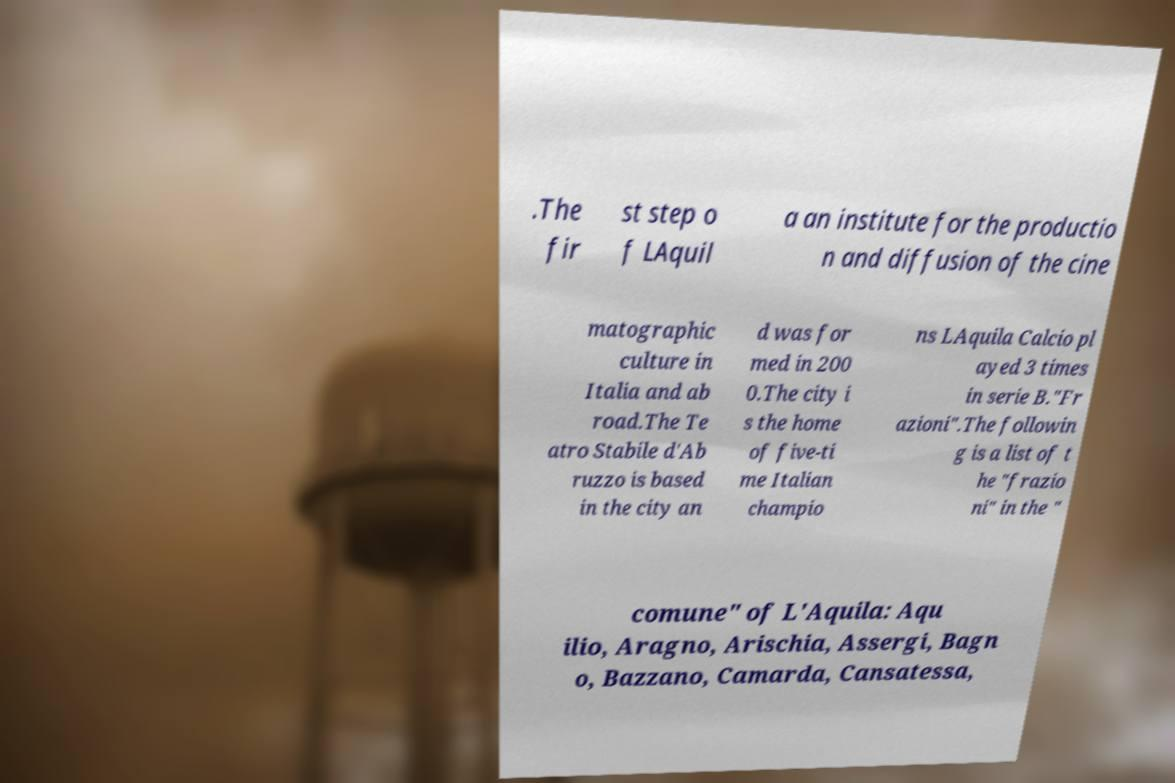For documentation purposes, I need the text within this image transcribed. Could you provide that? .The fir st step o f LAquil a an institute for the productio n and diffusion of the cine matographic culture in Italia and ab road.The Te atro Stabile d'Ab ruzzo is based in the city an d was for med in 200 0.The city i s the home of five-ti me Italian champio ns LAquila Calcio pl ayed 3 times in serie B."Fr azioni".The followin g is a list of t he "frazio ni" in the " comune" of L'Aquila: Aqu ilio, Aragno, Arischia, Assergi, Bagn o, Bazzano, Camarda, Cansatessa, 